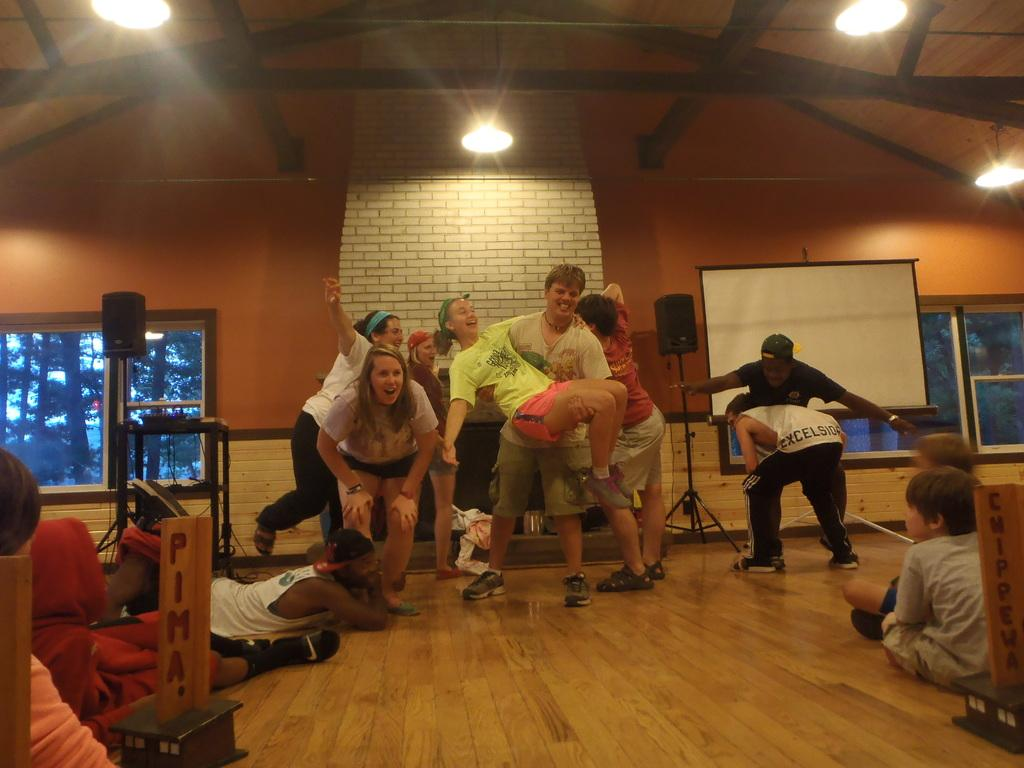<image>
Describe the image concisely. People playing next to a sign that is cut off saying Pima. 